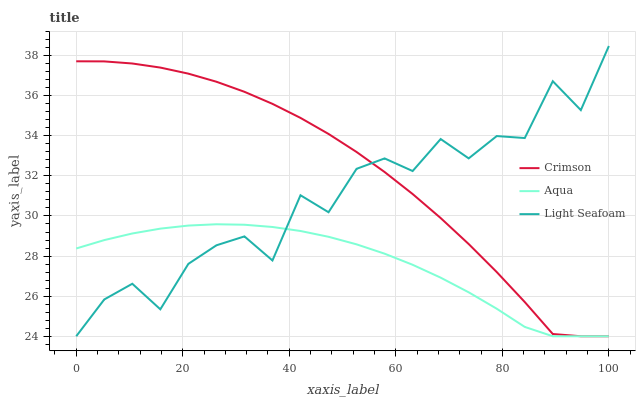Does Aqua have the minimum area under the curve?
Answer yes or no. Yes. Does Crimson have the maximum area under the curve?
Answer yes or no. Yes. Does Light Seafoam have the minimum area under the curve?
Answer yes or no. No. Does Light Seafoam have the maximum area under the curve?
Answer yes or no. No. Is Aqua the smoothest?
Answer yes or no. Yes. Is Light Seafoam the roughest?
Answer yes or no. Yes. Is Light Seafoam the smoothest?
Answer yes or no. No. Is Aqua the roughest?
Answer yes or no. No. Does Aqua have the highest value?
Answer yes or no. No. 